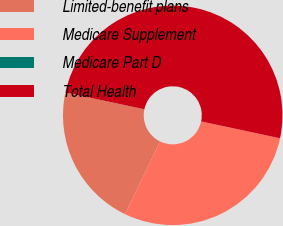Convert chart. <chart><loc_0><loc_0><loc_500><loc_500><pie_chart><fcel>Limited-benefit plans<fcel>Medicare Supplement<fcel>Medicare Part D<fcel>Total Health<nl><fcel>21.18%<fcel>28.82%<fcel>0.0%<fcel>50.0%<nl></chart> 